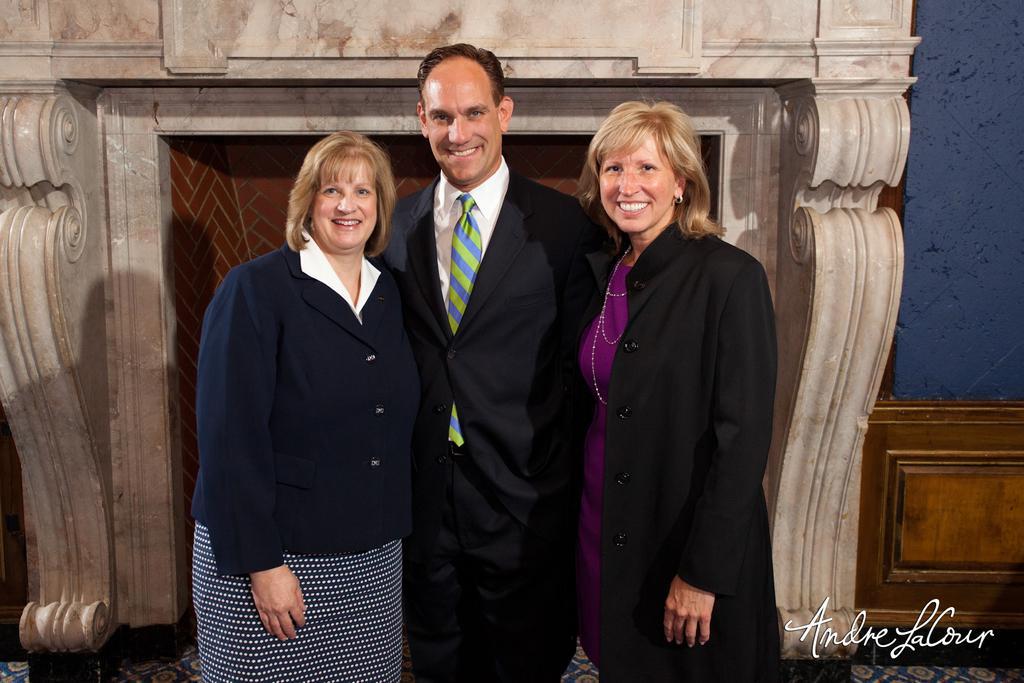In one or two sentences, can you explain what this image depicts? In this image, there are a few people. We can see the ground. We can see the fireplace. We can also see the wall and some wood. We can also see some text on the bottom right corner. 